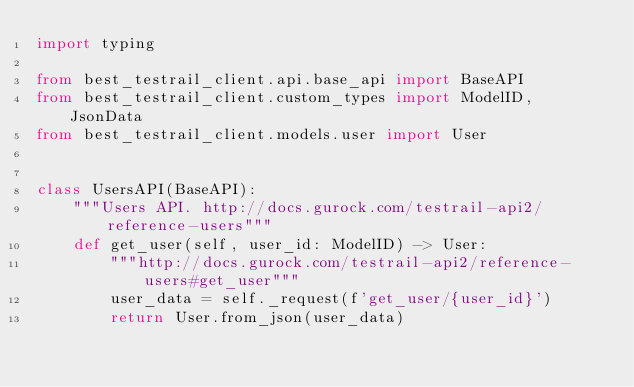Convert code to text. <code><loc_0><loc_0><loc_500><loc_500><_Python_>import typing

from best_testrail_client.api.base_api import BaseAPI
from best_testrail_client.custom_types import ModelID, JsonData
from best_testrail_client.models.user import User


class UsersAPI(BaseAPI):
    """Users API. http://docs.gurock.com/testrail-api2/reference-users"""
    def get_user(self, user_id: ModelID) -> User:
        """http://docs.gurock.com/testrail-api2/reference-users#get_user"""
        user_data = self._request(f'get_user/{user_id}')
        return User.from_json(user_data)
</code> 